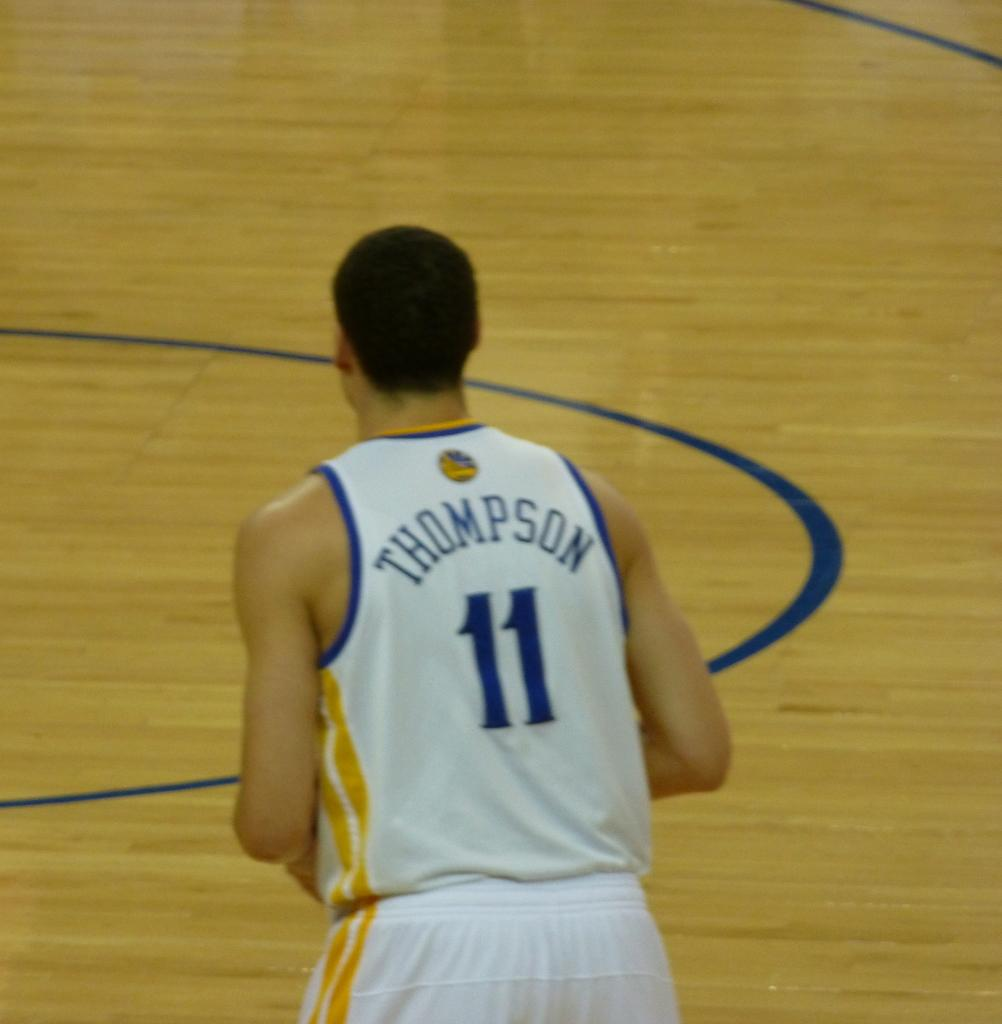<image>
Share a concise interpretation of the image provided. A basketball player has number 11 on the back of his jersey. 